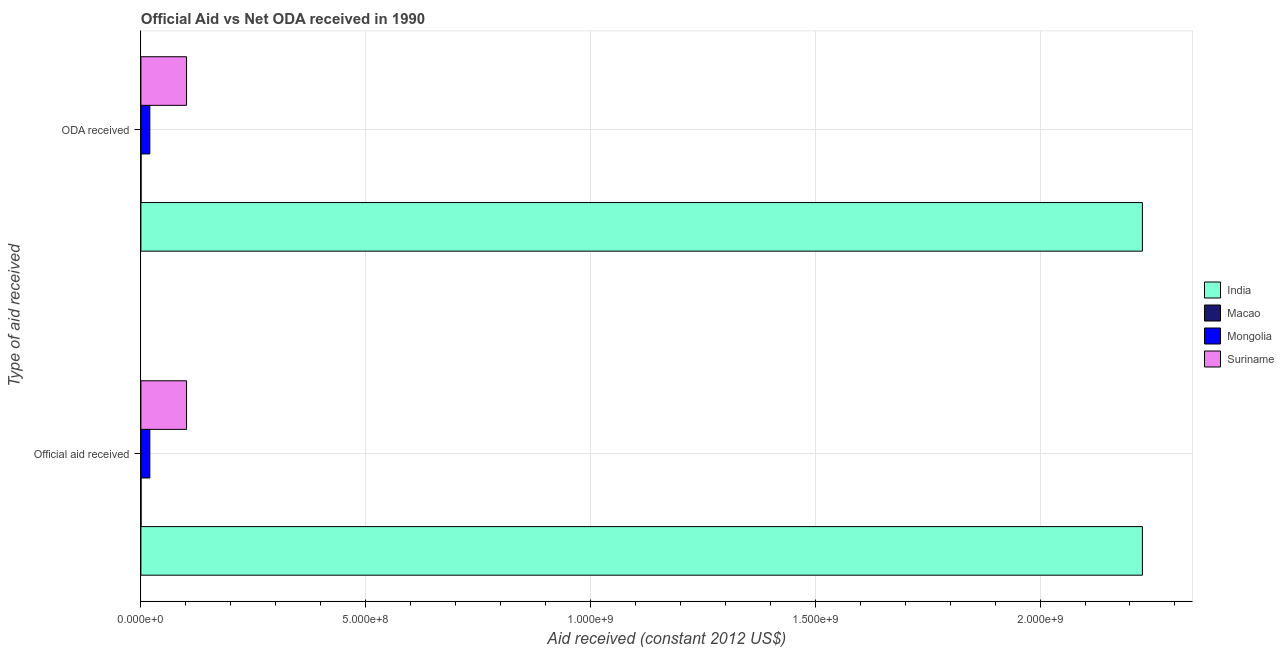How many groups of bars are there?
Give a very brief answer. 2. Are the number of bars per tick equal to the number of legend labels?
Offer a very short reply. Yes. Are the number of bars on each tick of the Y-axis equal?
Offer a very short reply. Yes. How many bars are there on the 2nd tick from the bottom?
Your answer should be compact. 4. What is the label of the 2nd group of bars from the top?
Ensure brevity in your answer.  Official aid received. What is the oda received in Mongolia?
Your answer should be very brief. 1.99e+07. Across all countries, what is the maximum oda received?
Provide a short and direct response. 2.23e+09. Across all countries, what is the minimum official aid received?
Keep it short and to the point. 3.60e+05. In which country was the oda received minimum?
Offer a very short reply. Macao. What is the total oda received in the graph?
Your response must be concise. 2.35e+09. What is the difference between the oda received in Mongolia and that in Macao?
Offer a terse response. 1.96e+07. What is the difference between the oda received in Suriname and the official aid received in India?
Offer a terse response. -2.13e+09. What is the average oda received per country?
Make the answer very short. 5.87e+08. What is the difference between the oda received and official aid received in Mongolia?
Keep it short and to the point. 0. In how many countries, is the oda received greater than 2200000000 US$?
Your answer should be very brief. 1. What is the ratio of the oda received in India to that in Suriname?
Offer a very short reply. 21.93. Is the oda received in Macao less than that in Suriname?
Your response must be concise. Yes. What does the 4th bar from the bottom in ODA received represents?
Your answer should be very brief. Suriname. How many bars are there?
Provide a succinct answer. 8. How many countries are there in the graph?
Give a very brief answer. 4. Does the graph contain grids?
Provide a succinct answer. Yes. How many legend labels are there?
Your response must be concise. 4. What is the title of the graph?
Ensure brevity in your answer.  Official Aid vs Net ODA received in 1990 . What is the label or title of the X-axis?
Your answer should be compact. Aid received (constant 2012 US$). What is the label or title of the Y-axis?
Offer a terse response. Type of aid received. What is the Aid received (constant 2012 US$) of India in Official aid received?
Your answer should be very brief. 2.23e+09. What is the Aid received (constant 2012 US$) of Mongolia in Official aid received?
Your response must be concise. 1.99e+07. What is the Aid received (constant 2012 US$) in Suriname in Official aid received?
Your answer should be very brief. 1.02e+08. What is the Aid received (constant 2012 US$) in India in ODA received?
Your response must be concise. 2.23e+09. What is the Aid received (constant 2012 US$) of Mongolia in ODA received?
Provide a succinct answer. 1.99e+07. What is the Aid received (constant 2012 US$) of Suriname in ODA received?
Make the answer very short. 1.02e+08. Across all Type of aid received, what is the maximum Aid received (constant 2012 US$) of India?
Give a very brief answer. 2.23e+09. Across all Type of aid received, what is the maximum Aid received (constant 2012 US$) of Macao?
Your answer should be very brief. 3.60e+05. Across all Type of aid received, what is the maximum Aid received (constant 2012 US$) of Mongolia?
Offer a very short reply. 1.99e+07. Across all Type of aid received, what is the maximum Aid received (constant 2012 US$) of Suriname?
Keep it short and to the point. 1.02e+08. Across all Type of aid received, what is the minimum Aid received (constant 2012 US$) of India?
Your answer should be very brief. 2.23e+09. Across all Type of aid received, what is the minimum Aid received (constant 2012 US$) of Macao?
Make the answer very short. 3.60e+05. Across all Type of aid received, what is the minimum Aid received (constant 2012 US$) of Mongolia?
Make the answer very short. 1.99e+07. Across all Type of aid received, what is the minimum Aid received (constant 2012 US$) in Suriname?
Offer a very short reply. 1.02e+08. What is the total Aid received (constant 2012 US$) in India in the graph?
Provide a short and direct response. 4.46e+09. What is the total Aid received (constant 2012 US$) in Macao in the graph?
Your answer should be very brief. 7.20e+05. What is the total Aid received (constant 2012 US$) of Mongolia in the graph?
Ensure brevity in your answer.  3.98e+07. What is the total Aid received (constant 2012 US$) in Suriname in the graph?
Provide a short and direct response. 2.03e+08. What is the difference between the Aid received (constant 2012 US$) in Macao in Official aid received and that in ODA received?
Your answer should be compact. 0. What is the difference between the Aid received (constant 2012 US$) in Mongolia in Official aid received and that in ODA received?
Offer a very short reply. 0. What is the difference between the Aid received (constant 2012 US$) in Suriname in Official aid received and that in ODA received?
Offer a very short reply. 0. What is the difference between the Aid received (constant 2012 US$) in India in Official aid received and the Aid received (constant 2012 US$) in Macao in ODA received?
Offer a terse response. 2.23e+09. What is the difference between the Aid received (constant 2012 US$) of India in Official aid received and the Aid received (constant 2012 US$) of Mongolia in ODA received?
Your response must be concise. 2.21e+09. What is the difference between the Aid received (constant 2012 US$) in India in Official aid received and the Aid received (constant 2012 US$) in Suriname in ODA received?
Your answer should be very brief. 2.13e+09. What is the difference between the Aid received (constant 2012 US$) in Macao in Official aid received and the Aid received (constant 2012 US$) in Mongolia in ODA received?
Provide a short and direct response. -1.96e+07. What is the difference between the Aid received (constant 2012 US$) of Macao in Official aid received and the Aid received (constant 2012 US$) of Suriname in ODA received?
Make the answer very short. -1.01e+08. What is the difference between the Aid received (constant 2012 US$) in Mongolia in Official aid received and the Aid received (constant 2012 US$) in Suriname in ODA received?
Keep it short and to the point. -8.17e+07. What is the average Aid received (constant 2012 US$) in India per Type of aid received?
Provide a short and direct response. 2.23e+09. What is the average Aid received (constant 2012 US$) of Mongolia per Type of aid received?
Keep it short and to the point. 1.99e+07. What is the average Aid received (constant 2012 US$) in Suriname per Type of aid received?
Make the answer very short. 1.02e+08. What is the difference between the Aid received (constant 2012 US$) in India and Aid received (constant 2012 US$) in Macao in Official aid received?
Make the answer very short. 2.23e+09. What is the difference between the Aid received (constant 2012 US$) of India and Aid received (constant 2012 US$) of Mongolia in Official aid received?
Your answer should be very brief. 2.21e+09. What is the difference between the Aid received (constant 2012 US$) in India and Aid received (constant 2012 US$) in Suriname in Official aid received?
Provide a succinct answer. 2.13e+09. What is the difference between the Aid received (constant 2012 US$) of Macao and Aid received (constant 2012 US$) of Mongolia in Official aid received?
Your response must be concise. -1.96e+07. What is the difference between the Aid received (constant 2012 US$) in Macao and Aid received (constant 2012 US$) in Suriname in Official aid received?
Your answer should be compact. -1.01e+08. What is the difference between the Aid received (constant 2012 US$) in Mongolia and Aid received (constant 2012 US$) in Suriname in Official aid received?
Keep it short and to the point. -8.17e+07. What is the difference between the Aid received (constant 2012 US$) in India and Aid received (constant 2012 US$) in Macao in ODA received?
Keep it short and to the point. 2.23e+09. What is the difference between the Aid received (constant 2012 US$) of India and Aid received (constant 2012 US$) of Mongolia in ODA received?
Your answer should be compact. 2.21e+09. What is the difference between the Aid received (constant 2012 US$) of India and Aid received (constant 2012 US$) of Suriname in ODA received?
Offer a terse response. 2.13e+09. What is the difference between the Aid received (constant 2012 US$) of Macao and Aid received (constant 2012 US$) of Mongolia in ODA received?
Offer a terse response. -1.96e+07. What is the difference between the Aid received (constant 2012 US$) in Macao and Aid received (constant 2012 US$) in Suriname in ODA received?
Ensure brevity in your answer.  -1.01e+08. What is the difference between the Aid received (constant 2012 US$) in Mongolia and Aid received (constant 2012 US$) in Suriname in ODA received?
Keep it short and to the point. -8.17e+07. What is the ratio of the Aid received (constant 2012 US$) of Mongolia in Official aid received to that in ODA received?
Your answer should be compact. 1. What is the difference between the highest and the second highest Aid received (constant 2012 US$) in India?
Your answer should be very brief. 0. What is the difference between the highest and the second highest Aid received (constant 2012 US$) in Macao?
Your answer should be compact. 0. What is the difference between the highest and the lowest Aid received (constant 2012 US$) of Macao?
Provide a short and direct response. 0. What is the difference between the highest and the lowest Aid received (constant 2012 US$) of Mongolia?
Your answer should be compact. 0. What is the difference between the highest and the lowest Aid received (constant 2012 US$) in Suriname?
Keep it short and to the point. 0. 